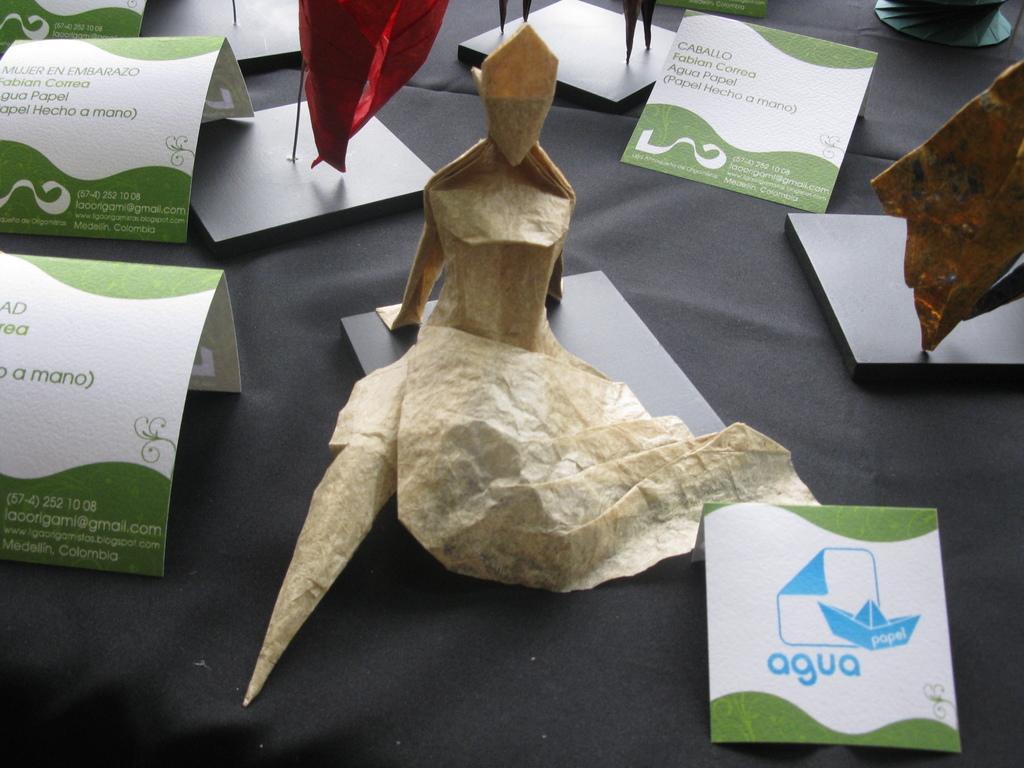How would you summarize this image in a sentence or two? In this image I can see few papers and also the paper arts. These are on the grey color sheet. 